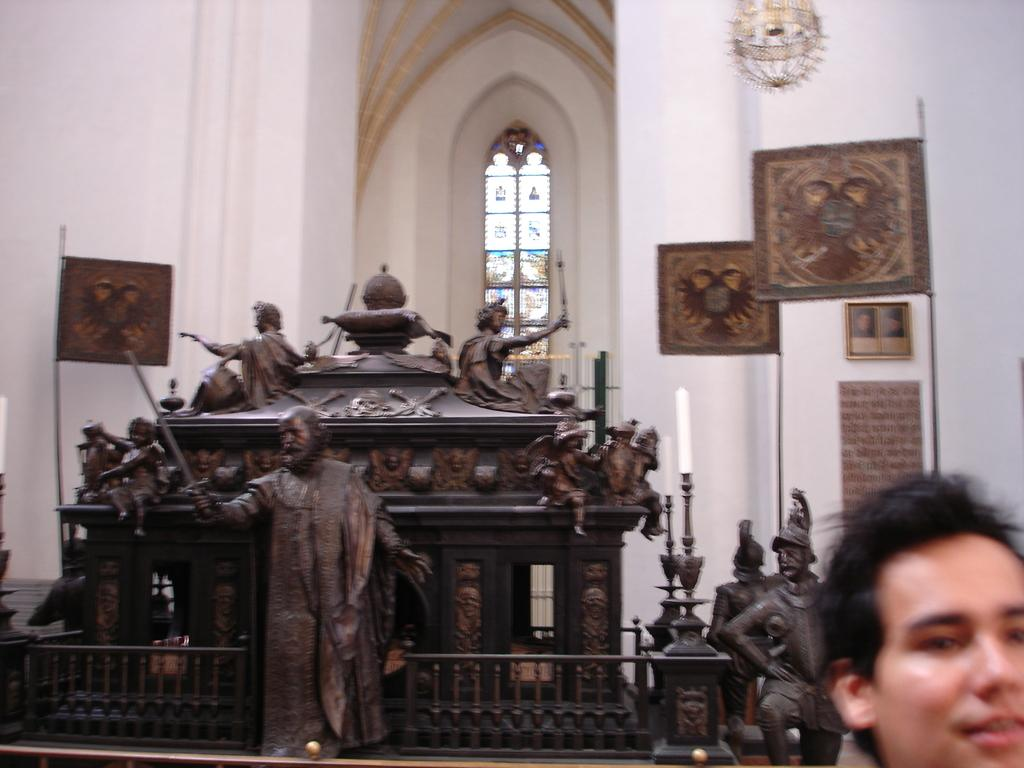What is the main subject in the middle of the image? There is a statue in the middle of the image. Where is the person's face located in the image? The person's face is in the bottom right corner of the image. What can be seen at the top of the image? There are lights at the top of the image. What objects are present in the middle of the image besides the statue? There are candles in the middle of the image. How many tomatoes are on the ground in the image? There are no tomatoes present in the image. Is there a camp visible in the image? There is no camp visible in the image. 